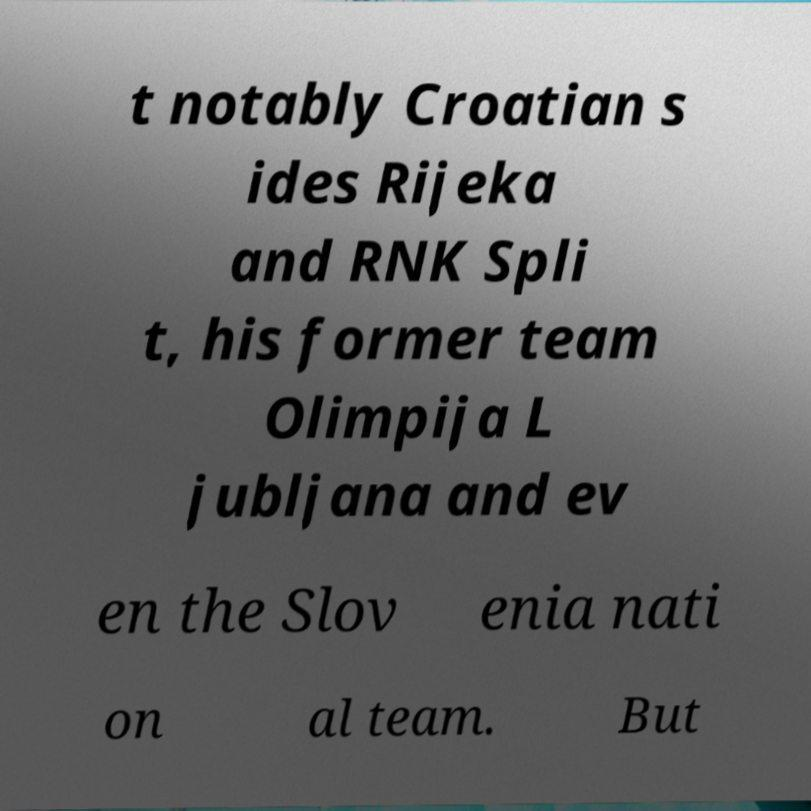Could you extract and type out the text from this image? t notably Croatian s ides Rijeka and RNK Spli t, his former team Olimpija L jubljana and ev en the Slov enia nati on al team. But 